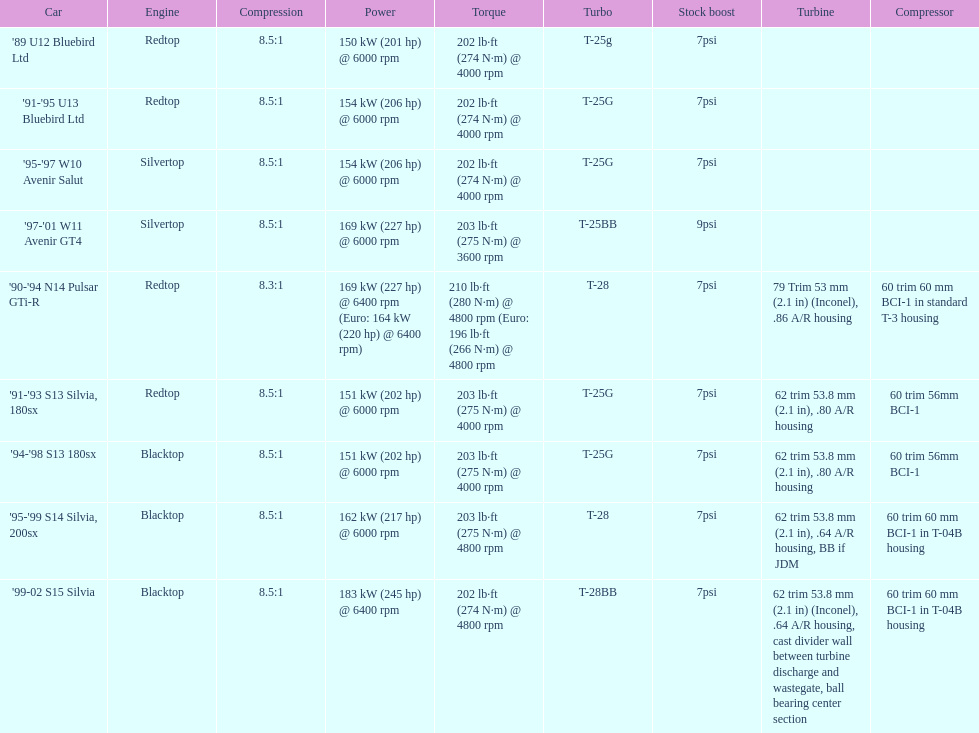Can you give me this table as a dict? {'header': ['Car', 'Engine', 'Compression', 'Power', 'Torque', 'Turbo', 'Stock boost', 'Turbine', 'Compressor'], 'rows': [["'89 U12 Bluebird Ltd", 'Redtop', '8.5:1', '150\xa0kW (201\xa0hp) @ 6000 rpm', '202\xa0lb·ft (274\xa0N·m) @ 4000 rpm', 'T-25g', '7psi', '', ''], ["'91-'95 U13 Bluebird Ltd", 'Redtop', '8.5:1', '154\xa0kW (206\xa0hp) @ 6000 rpm', '202\xa0lb·ft (274\xa0N·m) @ 4000 rpm', 'T-25G', '7psi', '', ''], ["'95-'97 W10 Avenir Salut", 'Silvertop', '8.5:1', '154\xa0kW (206\xa0hp) @ 6000 rpm', '202\xa0lb·ft (274\xa0N·m) @ 4000 rpm', 'T-25G', '7psi', '', ''], ["'97-'01 W11 Avenir GT4", 'Silvertop', '8.5:1', '169\xa0kW (227\xa0hp) @ 6000 rpm', '203\xa0lb·ft (275\xa0N·m) @ 3600 rpm', 'T-25BB', '9psi', '', ''], ["'90-'94 N14 Pulsar GTi-R", 'Redtop', '8.3:1', '169\xa0kW (227\xa0hp) @ 6400 rpm (Euro: 164\xa0kW (220\xa0hp) @ 6400 rpm)', '210\xa0lb·ft (280\xa0N·m) @ 4800 rpm (Euro: 196\xa0lb·ft (266\xa0N·m) @ 4800 rpm', 'T-28', '7psi', '79 Trim 53\xa0mm (2.1\xa0in) (Inconel), .86 A/R housing', '60 trim 60\xa0mm BCI-1 in standard T-3 housing'], ["'91-'93 S13 Silvia, 180sx", 'Redtop', '8.5:1', '151\xa0kW (202\xa0hp) @ 6000 rpm', '203\xa0lb·ft (275\xa0N·m) @ 4000 rpm', 'T-25G', '7psi', '62 trim 53.8\xa0mm (2.1\xa0in), .80 A/R housing', '60 trim 56mm BCI-1'], ["'94-'98 S13 180sx", 'Blacktop', '8.5:1', '151\xa0kW (202\xa0hp) @ 6000 rpm', '203\xa0lb·ft (275\xa0N·m) @ 4000 rpm', 'T-25G', '7psi', '62 trim 53.8\xa0mm (2.1\xa0in), .80 A/R housing', '60 trim 56mm BCI-1'], ["'95-'99 S14 Silvia, 200sx", 'Blacktop', '8.5:1', '162\xa0kW (217\xa0hp) @ 6000 rpm', '203\xa0lb·ft (275\xa0N·m) @ 4800 rpm', 'T-28', '7psi', '62 trim 53.8\xa0mm (2.1\xa0in), .64 A/R housing, BB if JDM', '60 trim 60\xa0mm BCI-1 in T-04B housing'], ["'99-02 S15 Silvia", 'Blacktop', '8.5:1', '183\xa0kW (245\xa0hp) @ 6400 rpm', '202\xa0lb·ft (274\xa0N·m) @ 4800 rpm', 'T-28BB', '7psi', '62 trim 53.8\xa0mm (2.1\xa0in) (Inconel), .64 A/R housing, cast divider wall between turbine discharge and wastegate, ball bearing center section', '60 trim 60\xa0mm BCI-1 in T-04B housing']]} Which engines are equivalent to the first record ('89 u12 bluebird ltd)? '91-'95 U13 Bluebird Ltd, '90-'94 N14 Pulsar GTi-R, '91-'93 S13 Silvia, 180sx. 